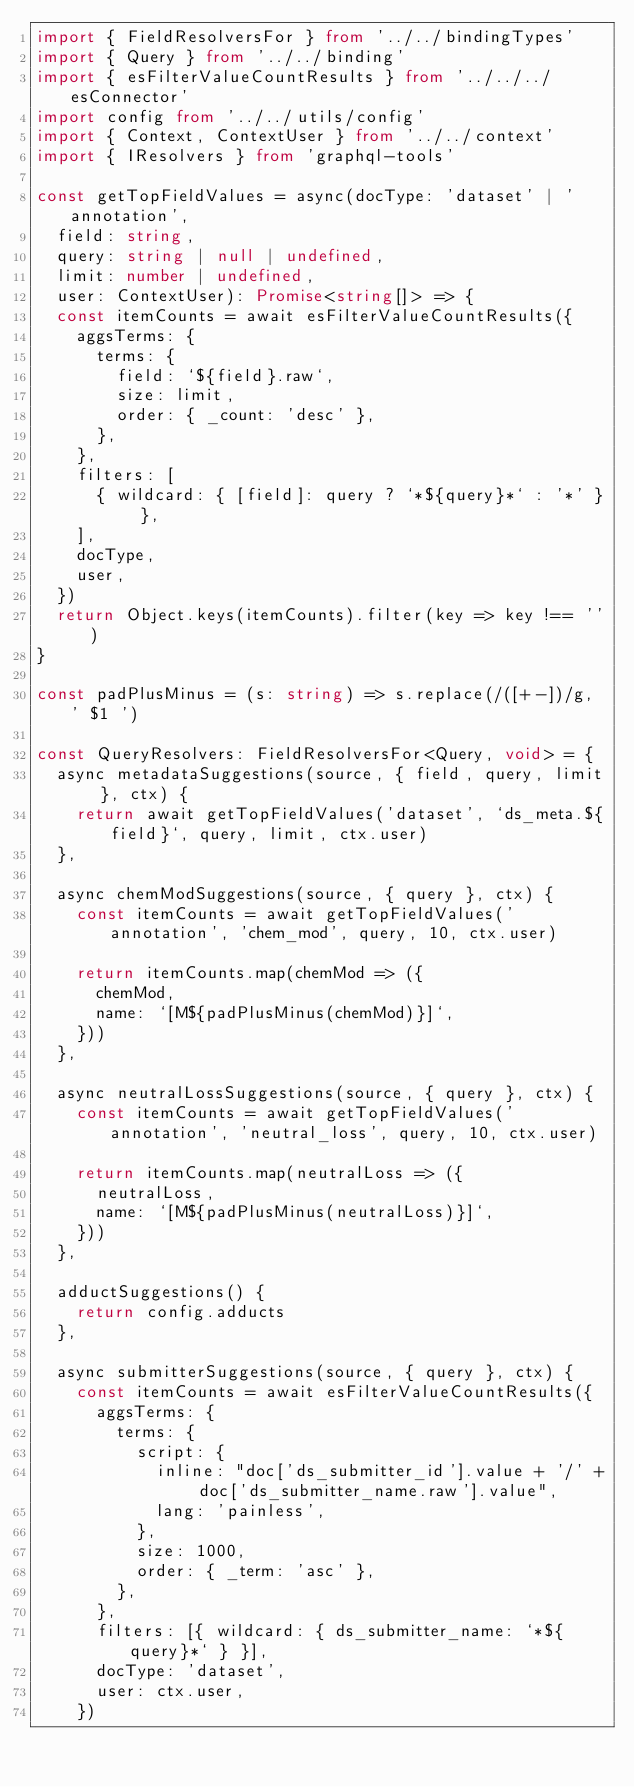Convert code to text. <code><loc_0><loc_0><loc_500><loc_500><_TypeScript_>import { FieldResolversFor } from '../../bindingTypes'
import { Query } from '../../binding'
import { esFilterValueCountResults } from '../../../esConnector'
import config from '../../utils/config'
import { Context, ContextUser } from '../../context'
import { IResolvers } from 'graphql-tools'

const getTopFieldValues = async(docType: 'dataset' | 'annotation',
  field: string,
  query: string | null | undefined,
  limit: number | undefined,
  user: ContextUser): Promise<string[]> => {
  const itemCounts = await esFilterValueCountResults({
    aggsTerms: {
      terms: {
        field: `${field}.raw`,
        size: limit,
        order: { _count: 'desc' },
      },
    },
    filters: [
      { wildcard: { [field]: query ? `*${query}*` : '*' } },
    ],
    docType,
    user,
  })
  return Object.keys(itemCounts).filter(key => key !== '')
}

const padPlusMinus = (s: string) => s.replace(/([+-])/g, ' $1 ')

const QueryResolvers: FieldResolversFor<Query, void> = {
  async metadataSuggestions(source, { field, query, limit }, ctx) {
    return await getTopFieldValues('dataset', `ds_meta.${field}`, query, limit, ctx.user)
  },

  async chemModSuggestions(source, { query }, ctx) {
    const itemCounts = await getTopFieldValues('annotation', 'chem_mod', query, 10, ctx.user)

    return itemCounts.map(chemMod => ({
      chemMod,
      name: `[M${padPlusMinus(chemMod)}]`,
    }))
  },

  async neutralLossSuggestions(source, { query }, ctx) {
    const itemCounts = await getTopFieldValues('annotation', 'neutral_loss', query, 10, ctx.user)

    return itemCounts.map(neutralLoss => ({
      neutralLoss,
      name: `[M${padPlusMinus(neutralLoss)}]`,
    }))
  },

  adductSuggestions() {
    return config.adducts
  },

  async submitterSuggestions(source, { query }, ctx) {
    const itemCounts = await esFilterValueCountResults({
      aggsTerms: {
        terms: {
          script: {
            inline: "doc['ds_submitter_id'].value + '/' + doc['ds_submitter_name.raw'].value",
            lang: 'painless',
          },
          size: 1000,
          order: { _term: 'asc' },
        },
      },
      filters: [{ wildcard: { ds_submitter_name: `*${query}*` } }],
      docType: 'dataset',
      user: ctx.user,
    })</code> 